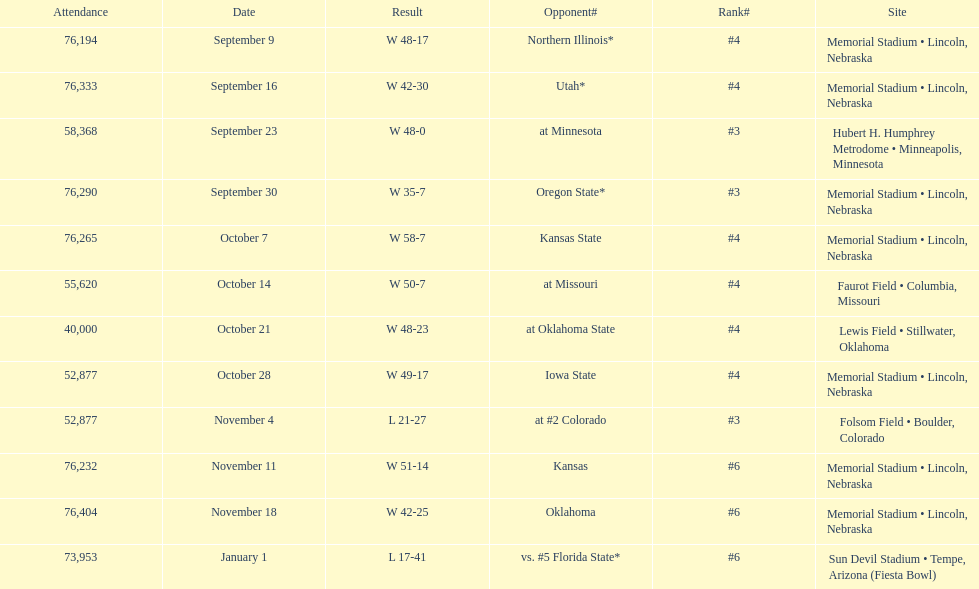What site at most is taken place? Memorial Stadium • Lincoln, Nebraska. 